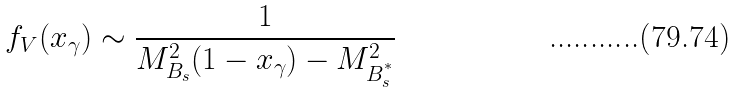Convert formula to latex. <formula><loc_0><loc_0><loc_500><loc_500>f _ { V } ( x _ { \gamma } ) \sim \frac { 1 } { M ^ { 2 } _ { B _ { s } } ( 1 - x _ { \gamma } ) - M ^ { 2 } _ { B ^ { ^ { * } } _ { s } } }</formula> 